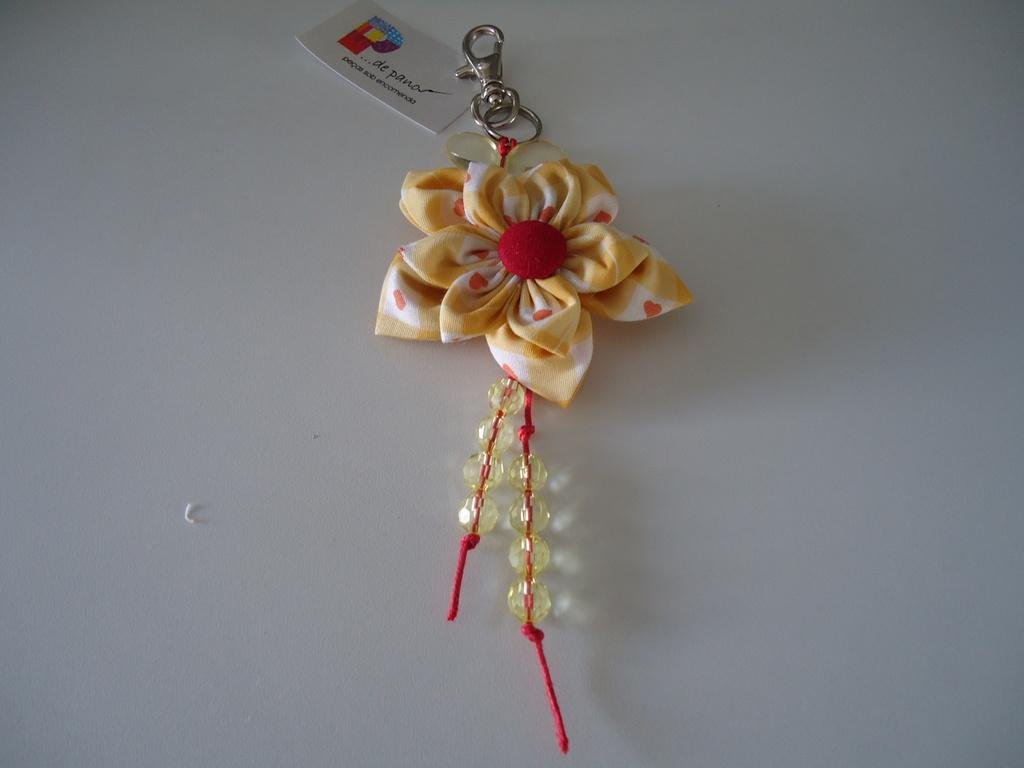What object is the main focus of the image? There is a key chain in the image. Where is the key chain located in the image? The key chain is in the center of the image. What colors are present on the key chain? The key chain is yellow and red in color. What type of cup is being used to observe the burst of colors in the image? There is no cup or burst of colors present in the image; it features a key chain in the center. 